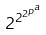Convert formula to latex. <formula><loc_0><loc_0><loc_500><loc_500>2 ^ { 2 ^ { 2 ^ { p ^ { a } } } }</formula> 